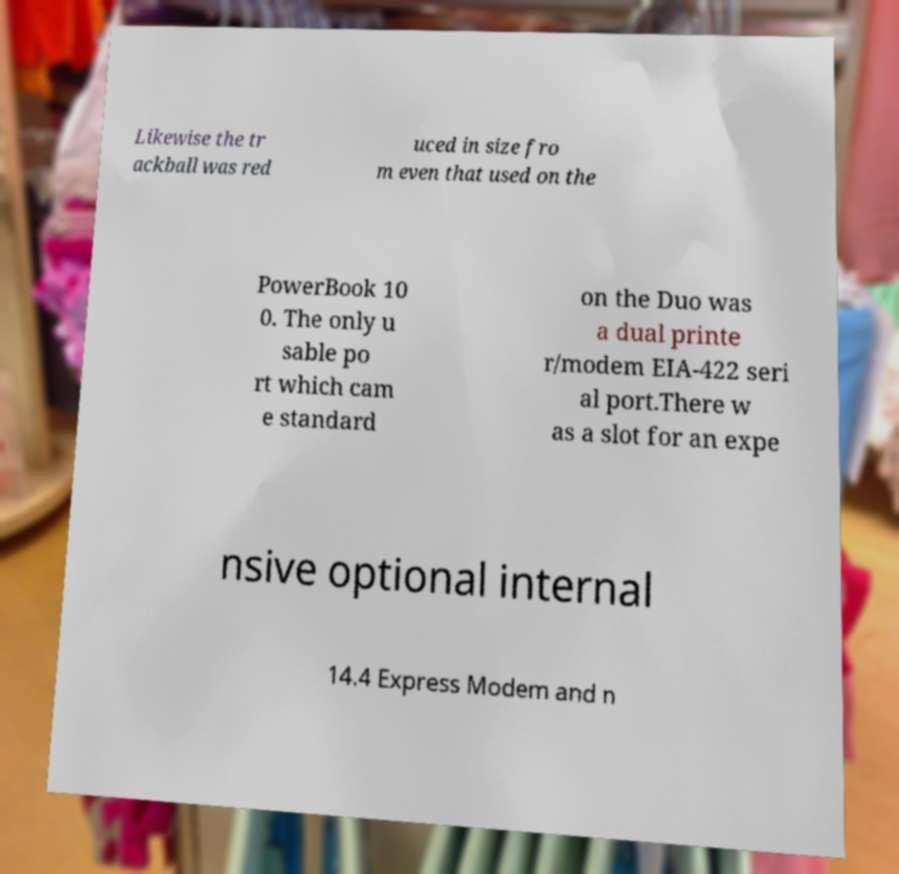For documentation purposes, I need the text within this image transcribed. Could you provide that? Likewise the tr ackball was red uced in size fro m even that used on the PowerBook 10 0. The only u sable po rt which cam e standard on the Duo was a dual printe r/modem EIA-422 seri al port.There w as a slot for an expe nsive optional internal 14.4 Express Modem and n 